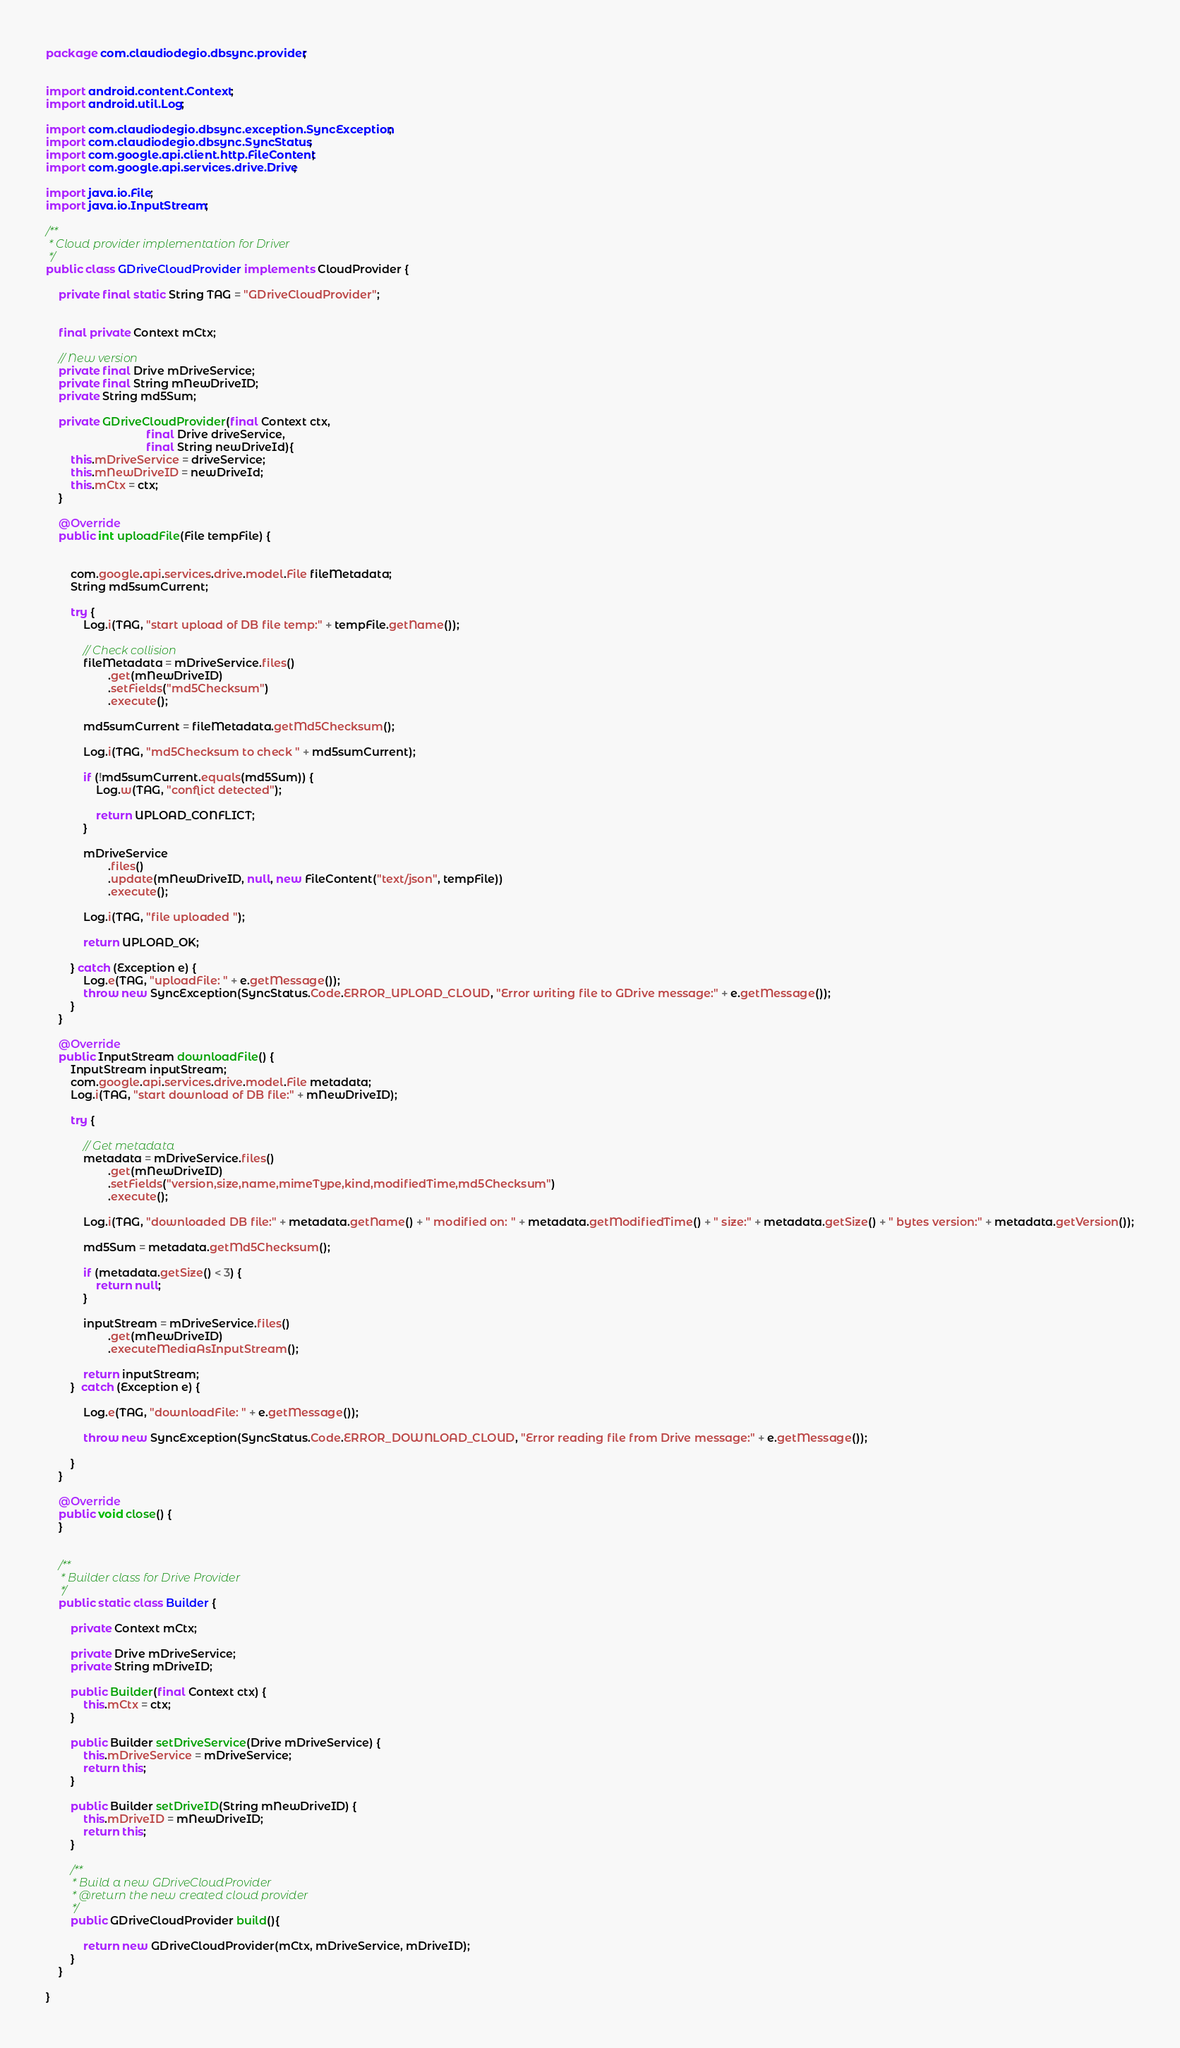Convert code to text. <code><loc_0><loc_0><loc_500><loc_500><_Java_>package com.claudiodegio.dbsync.provider;


import android.content.Context;
import android.util.Log;

import com.claudiodegio.dbsync.exception.SyncException;
import com.claudiodegio.dbsync.SyncStatus;
import com.google.api.client.http.FileContent;
import com.google.api.services.drive.Drive;

import java.io.File;
import java.io.InputStream;

/**
 * Cloud provider implementation for Driver
 */
public class GDriveCloudProvider implements CloudProvider {

    private final static String TAG = "GDriveCloudProvider";


    final private Context mCtx;

    // New version
    private final Drive mDriveService;
    private final String mNewDriveID;
    private String md5Sum;

    private GDriveCloudProvider(final Context ctx,
                                final Drive driveService,
                                final String newDriveId){
        this.mDriveService = driveService;
        this.mNewDriveID = newDriveId;
        this.mCtx = ctx;
    }

    @Override
    public int uploadFile(File tempFile) {


        com.google.api.services.drive.model.File fileMetadata;
        String md5sumCurrent;

        try {
            Log.i(TAG, "start upload of DB file temp:" + tempFile.getName());

            // Check collision
            fileMetadata = mDriveService.files()
                    .get(mNewDriveID)
                    .setFields("md5Checksum")
                    .execute();

            md5sumCurrent = fileMetadata.getMd5Checksum();

            Log.i(TAG, "md5Checksum to check " + md5sumCurrent);

            if (!md5sumCurrent.equals(md5Sum)) {
                Log.w(TAG, "conflict detected");

                return UPLOAD_CONFLICT;
            }

            mDriveService
                    .files()
                    .update(mNewDriveID, null, new FileContent("text/json", tempFile))
                    .execute();

            Log.i(TAG, "file uploaded ");

            return UPLOAD_OK;

        } catch (Exception e) {
            Log.e(TAG, "uploadFile: " + e.getMessage());
            throw new SyncException(SyncStatus.Code.ERROR_UPLOAD_CLOUD, "Error writing file to GDrive message:" + e.getMessage());
        }
    }

    @Override
    public InputStream downloadFile() {
        InputStream inputStream;
        com.google.api.services.drive.model.File metadata;
        Log.i(TAG, "start download of DB file:" + mNewDriveID);

        try {

            // Get metadata
            metadata = mDriveService.files()
                    .get(mNewDriveID)
                    .setFields("version,size,name,mimeType,kind,modifiedTime,md5Checksum")
                    .execute();

            Log.i(TAG, "downloaded DB file:" + metadata.getName() + " modified on: " + metadata.getModifiedTime() + " size:" + metadata.getSize() + " bytes version:" + metadata.getVersion());

            md5Sum = metadata.getMd5Checksum();

            if (metadata.getSize() < 3) {
                return null;
            }

            inputStream = mDriveService.files()
                    .get(mNewDriveID)
                    .executeMediaAsInputStream();

            return inputStream;
        }  catch (Exception e) {

            Log.e(TAG, "downloadFile: " + e.getMessage());

            throw new SyncException(SyncStatus.Code.ERROR_DOWNLOAD_CLOUD, "Error reading file from Drive message:" + e.getMessage());

        }
    }

    @Override
    public void close() {
    }


    /**
     * Builder class for Drive Provider
     */
    public static class Builder {

        private Context mCtx;

        private Drive mDriveService;
        private String mDriveID;

        public Builder(final Context ctx) {
            this.mCtx = ctx;
        }

        public Builder setDriveService(Drive mDriveService) {
            this.mDriveService = mDriveService;
            return this;
        }

        public Builder setDriveID(String mNewDriveID) {
            this.mDriveID = mNewDriveID;
            return this;
        }

        /**
         * Build a new GDriveCloudProvider
         * @return the new created cloud provider
         */
        public GDriveCloudProvider build(){

            return new GDriveCloudProvider(mCtx, mDriveService, mDriveID);
        }
    }

}
</code> 